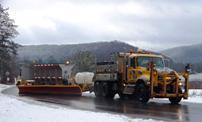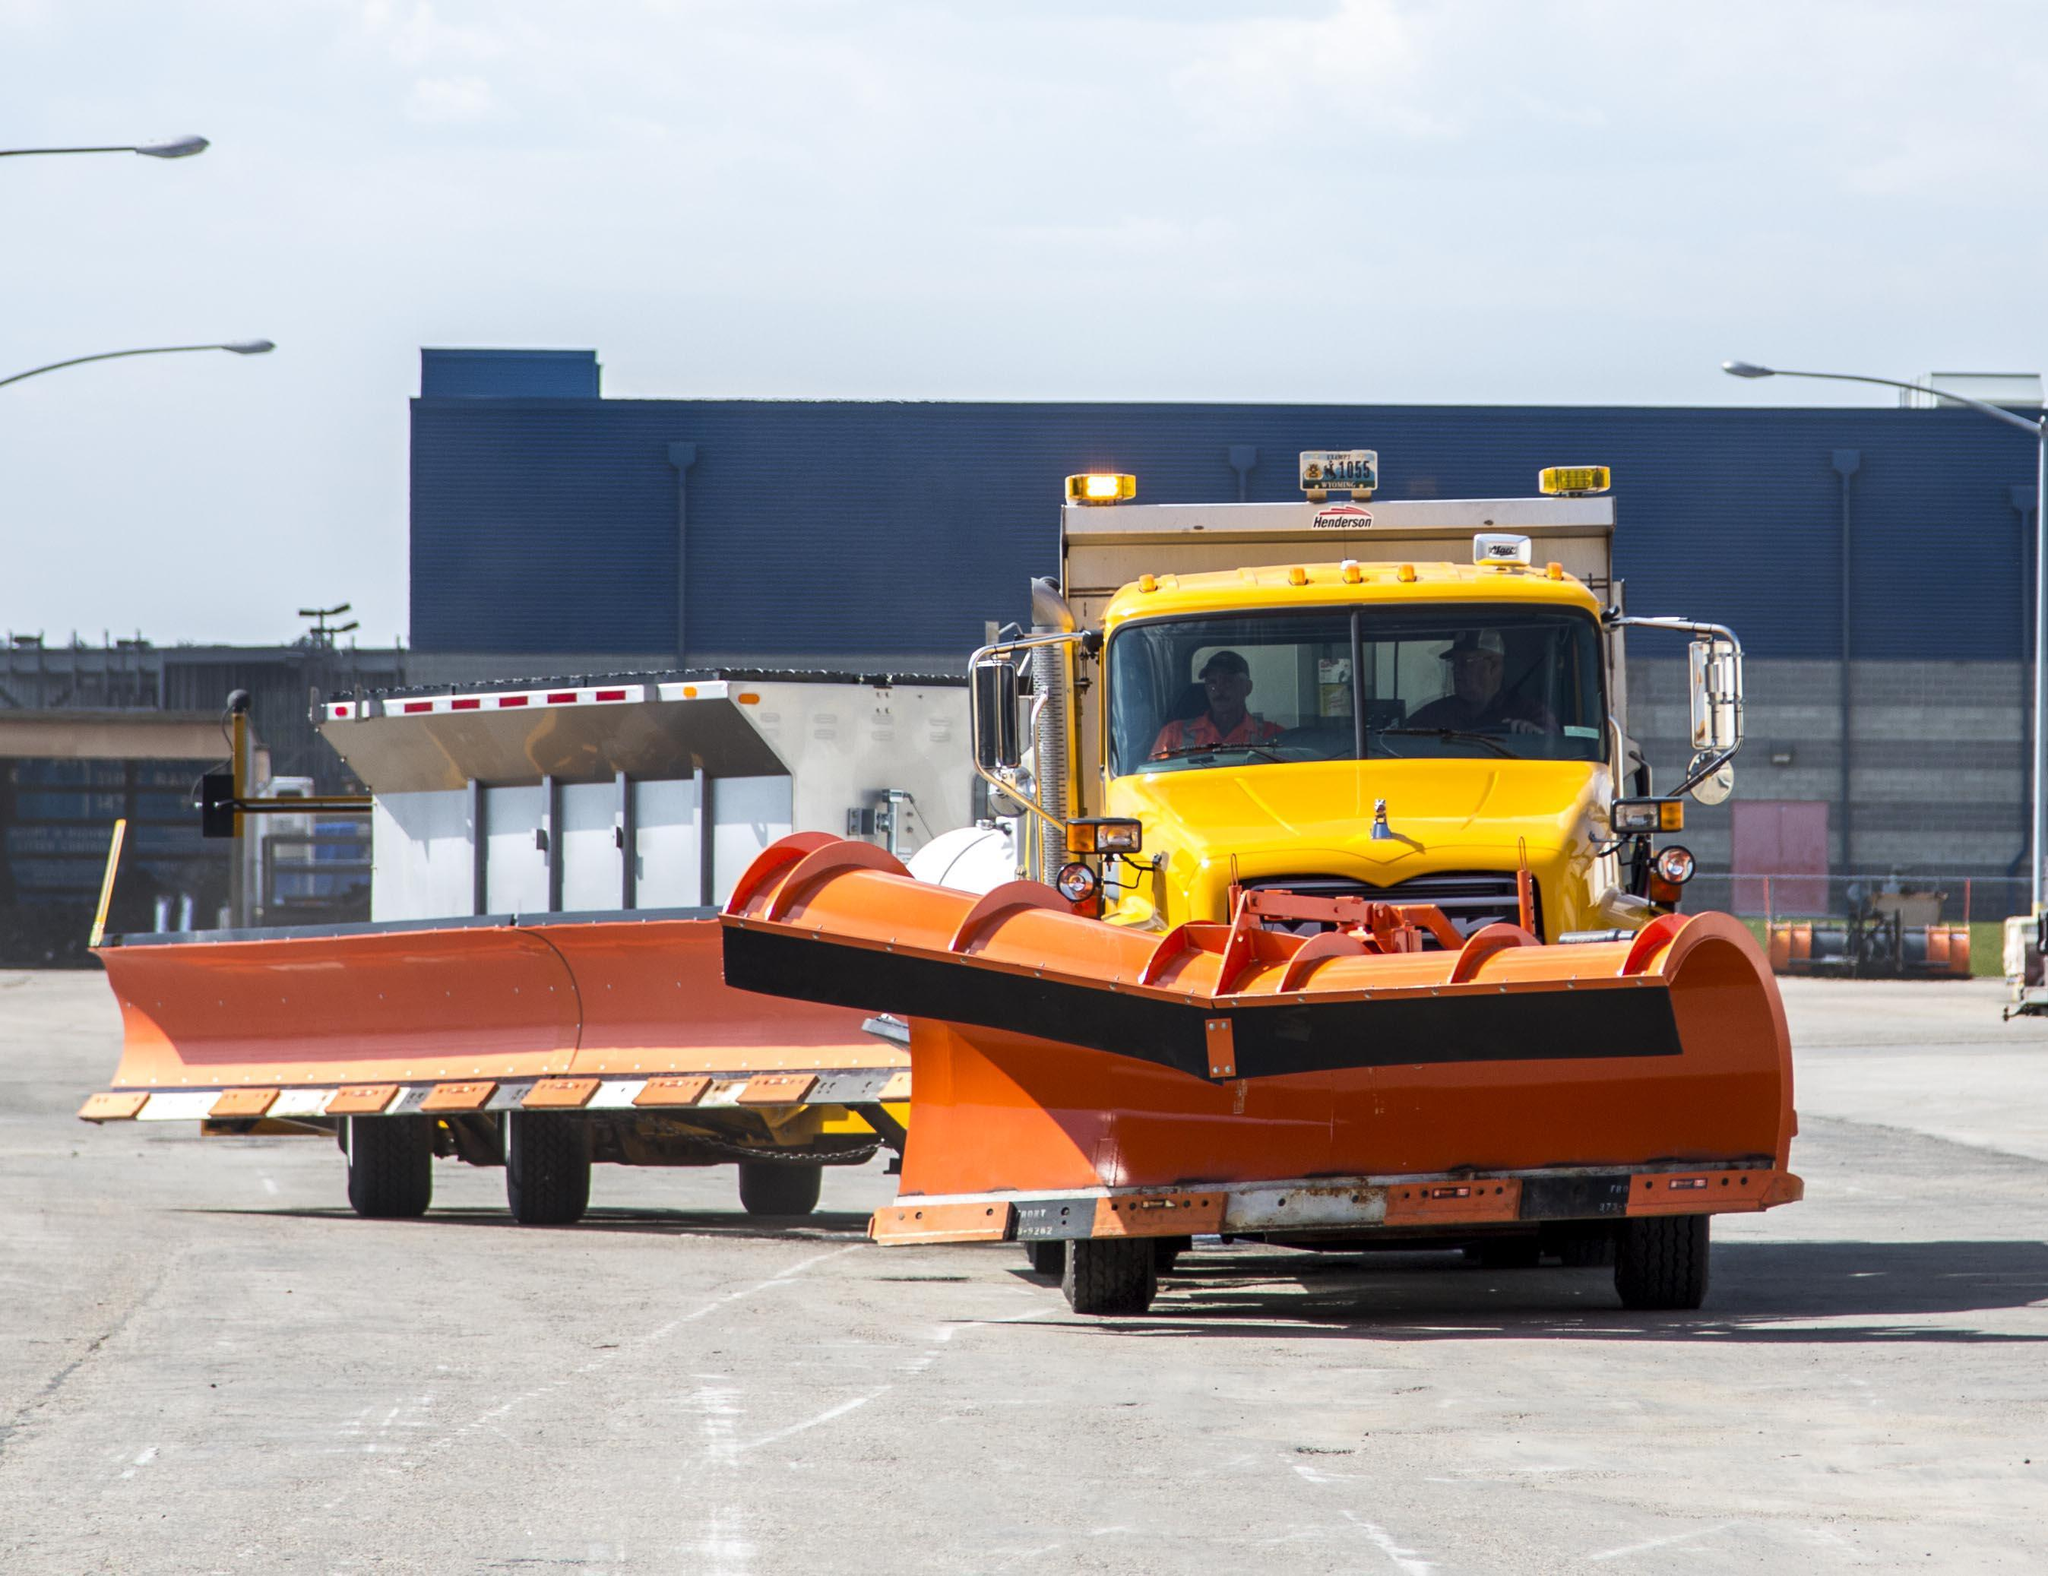The first image is the image on the left, the second image is the image on the right. For the images displayed, is the sentence "At the center of one image is a truck without a snow plow attached in front, and the truck has a yellow cab." factually correct? Answer yes or no. Yes. The first image is the image on the left, the second image is the image on the right. Considering the images on both sides, is "A yellow truck is facing left." valid? Answer yes or no. No. 